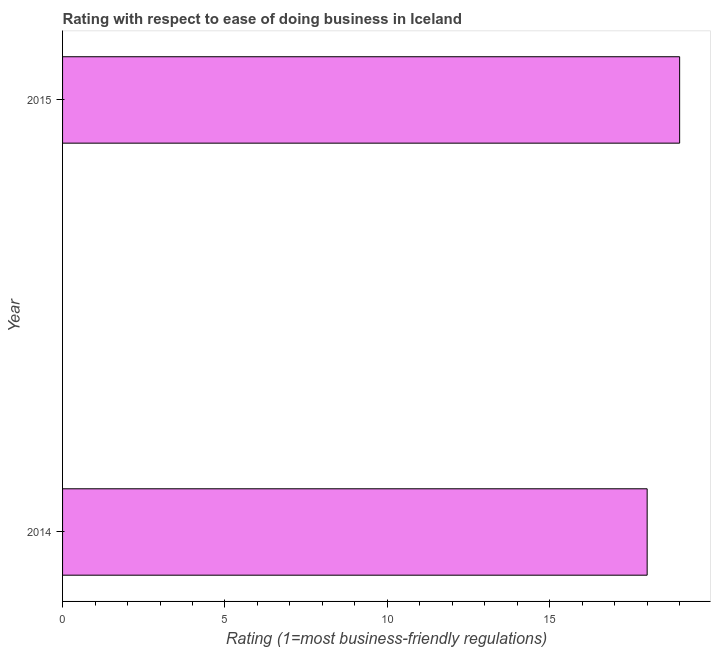What is the title of the graph?
Give a very brief answer. Rating with respect to ease of doing business in Iceland. What is the label or title of the X-axis?
Offer a very short reply. Rating (1=most business-friendly regulations). What is the ease of doing business index in 2014?
Offer a very short reply. 18. In which year was the ease of doing business index maximum?
Ensure brevity in your answer.  2015. What is the sum of the ease of doing business index?
Provide a short and direct response. 37. What is the difference between the ease of doing business index in 2014 and 2015?
Your answer should be compact. -1. In how many years, is the ease of doing business index greater than 15 ?
Offer a terse response. 2. Do a majority of the years between 2015 and 2014 (inclusive) have ease of doing business index greater than 10 ?
Ensure brevity in your answer.  No. What is the ratio of the ease of doing business index in 2014 to that in 2015?
Your answer should be very brief. 0.95. How many bars are there?
Offer a terse response. 2. How many years are there in the graph?
Make the answer very short. 2. What is the difference between two consecutive major ticks on the X-axis?
Your answer should be compact. 5. What is the Rating (1=most business-friendly regulations) in 2014?
Offer a terse response. 18. What is the Rating (1=most business-friendly regulations) of 2015?
Give a very brief answer. 19. What is the difference between the Rating (1=most business-friendly regulations) in 2014 and 2015?
Ensure brevity in your answer.  -1. What is the ratio of the Rating (1=most business-friendly regulations) in 2014 to that in 2015?
Offer a terse response. 0.95. 